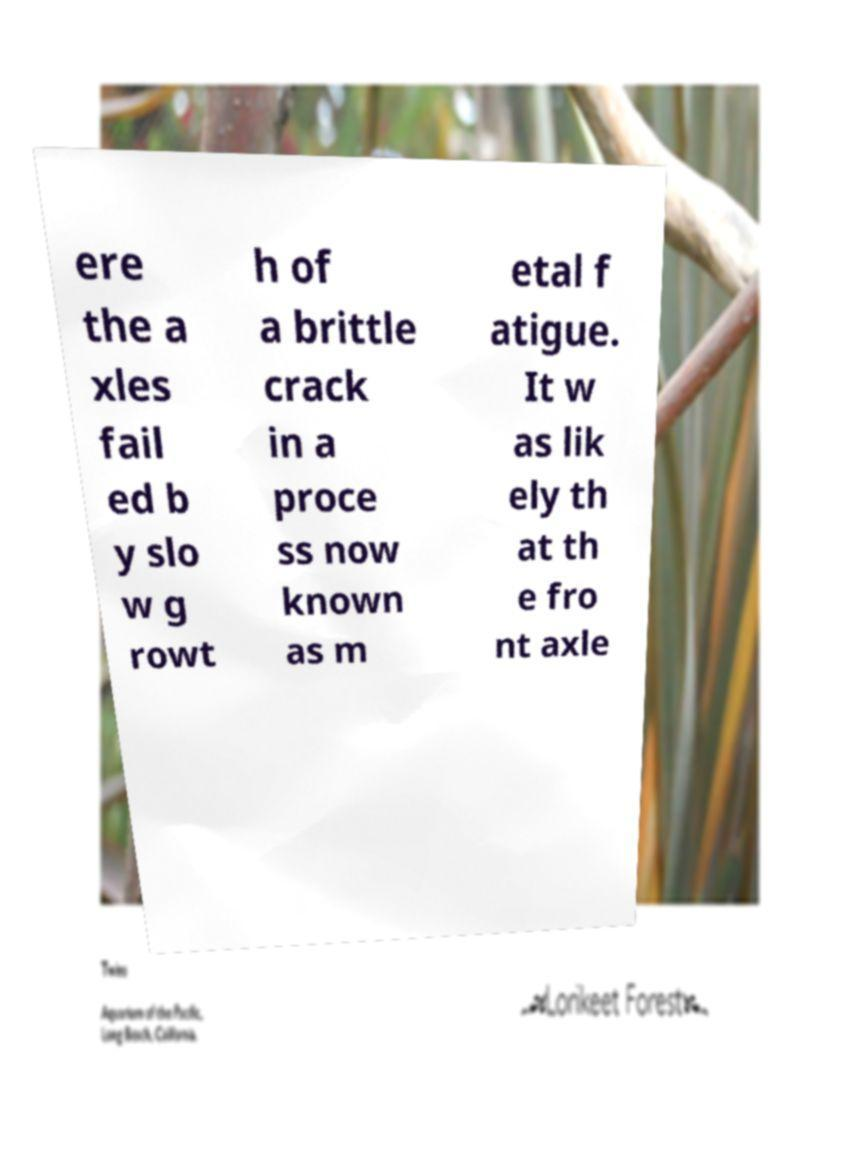There's text embedded in this image that I need extracted. Can you transcribe it verbatim? ere the a xles fail ed b y slo w g rowt h of a brittle crack in a proce ss now known as m etal f atigue. It w as lik ely th at th e fro nt axle 